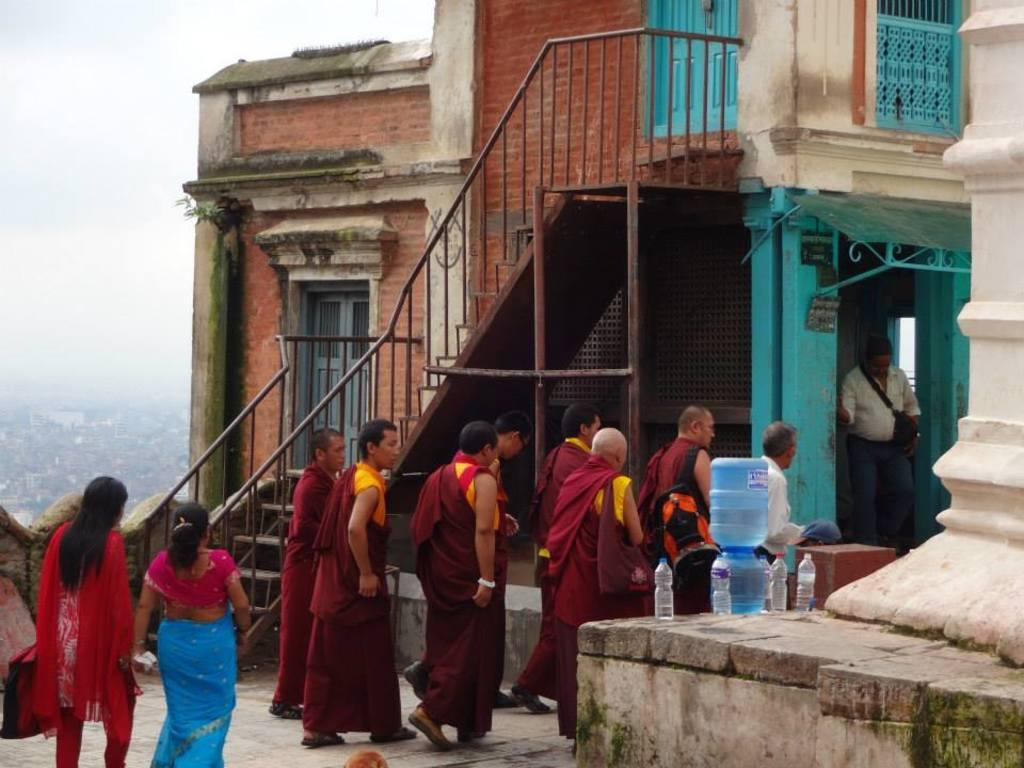What are the people in the image doing? The people in the image are walking on the ground. What can be seen in the background of the image? There is a building in the background of the image. What type of containers are present in the image? Tins and water bottles are present in the image. What is visible in the sky in the image? The sky is visible in the image. What type of fruit is being used by the police in the image? There is no police or fruit present in the image. 